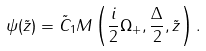Convert formula to latex. <formula><loc_0><loc_0><loc_500><loc_500>\psi ( \tilde { z } ) = \tilde { C } _ { 1 } M \left ( \frac { i } { 2 } \Omega _ { + } , \frac { \Delta } { 2 } , \tilde { z } \right ) .</formula> 